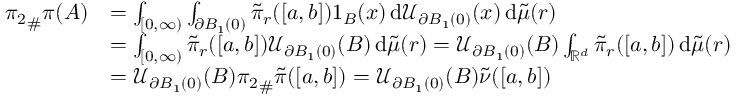<formula> <loc_0><loc_0><loc_500><loc_500>\begin{array} { r l } { { \pi _ { 2 } } _ { \# } \pi ( A ) } & { = \int _ { [ 0 , \infty ) } \int _ { \partial B _ { 1 } ( 0 ) } \tilde { \pi } _ { r } ( [ a , b ] ) 1 _ { B } ( x ) \, d \mathcal { U } _ { \partial B _ { 1 } ( 0 ) } ( x ) \, d \tilde { \mu } ( r ) } \\ & { = \int _ { [ 0 , \infty ) } \tilde { \pi } _ { r } ( [ a , b ] ) \mathcal { U } _ { \partial B _ { 1 } ( 0 ) } ( B ) \, d \tilde { \mu } ( r ) = \mathcal { U } _ { \partial B _ { 1 } ( 0 ) } ( B ) \int _ { \mathbb { R } ^ { d } } \tilde { \pi } _ { r } ( [ a , b ] ) \, d \tilde { \mu } ( r ) } \\ & { = \mathcal { U } _ { \partial B _ { 1 } ( 0 ) } ( B ) { \pi _ { 2 } } _ { \# } \tilde { \pi } ( [ a , b ] ) = \mathcal { U } _ { \partial B _ { 1 } ( 0 ) } ( B ) \tilde { \nu } ( [ a , b ] ) } \end{array}</formula> 